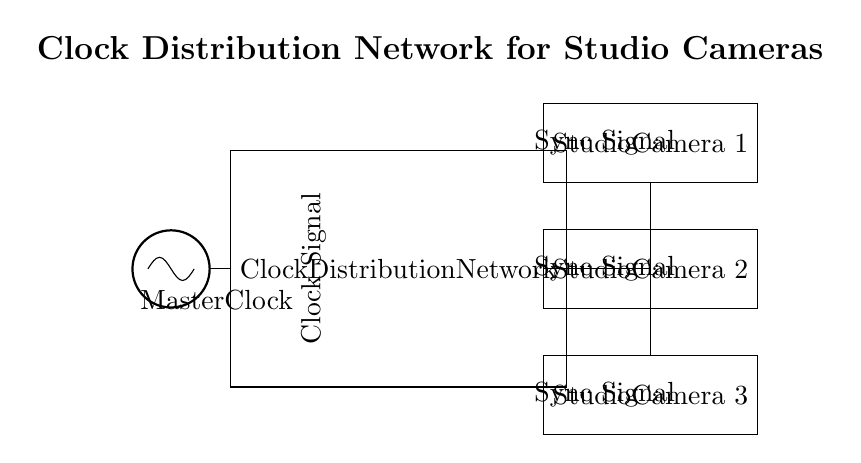What is the main component in this circuit? The main component is the Master Clock, which generates the clock signal necessary for synchronizing the studio cameras.
Answer: Master Clock What does the Clock Distribution Network do? The Clock Distribution Network distributes the clock signal from the Master Clock to multiple studio cameras, ensuring they are synchronized.
Answer: Distributes clock signal How many studio cameras are connected to the network? There are three studio cameras connected to the Clock Distribution Network, as indicated by their labels in the diagram.
Answer: Three What type of signals are sent to the studio cameras? Sync signals are sent to the studio cameras from the Clock Distribution Network to coordinate their operation accurately.
Answer: Sync Signals Which studio camera receives the clock signal using a different connection type? Studio Camera 1 uses a different connection type (a branch) to receive the clock signal in a non-linear manner, as seen in the circuit.
Answer: Studio Camera 1 Why is synchronization important for studio cameras? Synchronization is essential for studio cameras to avoid drift between footage, ensuring seamless video production and improved visual quality.
Answer: Avoid drift How does the Master Clock connect to the distribution network? The Master Clock connects directly to the Clock Distribution Network with a straight signal line, indicating a clear transmission path for the clock signal.
Answer: Direct connection 